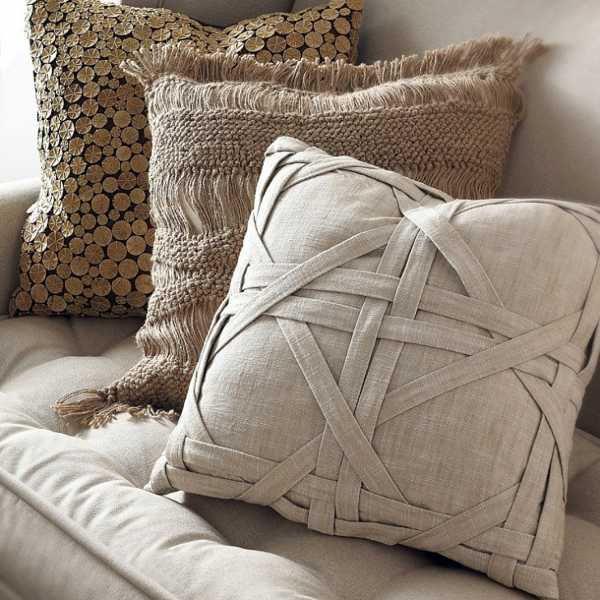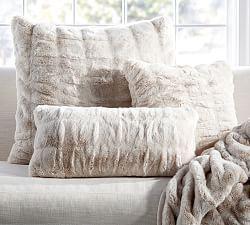The first image is the image on the left, the second image is the image on the right. Examine the images to the left and right. Is the description "A window is letting in natural light." accurate? Answer yes or no. Yes. The first image is the image on the left, the second image is the image on the right. For the images displayed, is the sentence "Each image features a bed made up with different pillows." factually correct? Answer yes or no. No. 